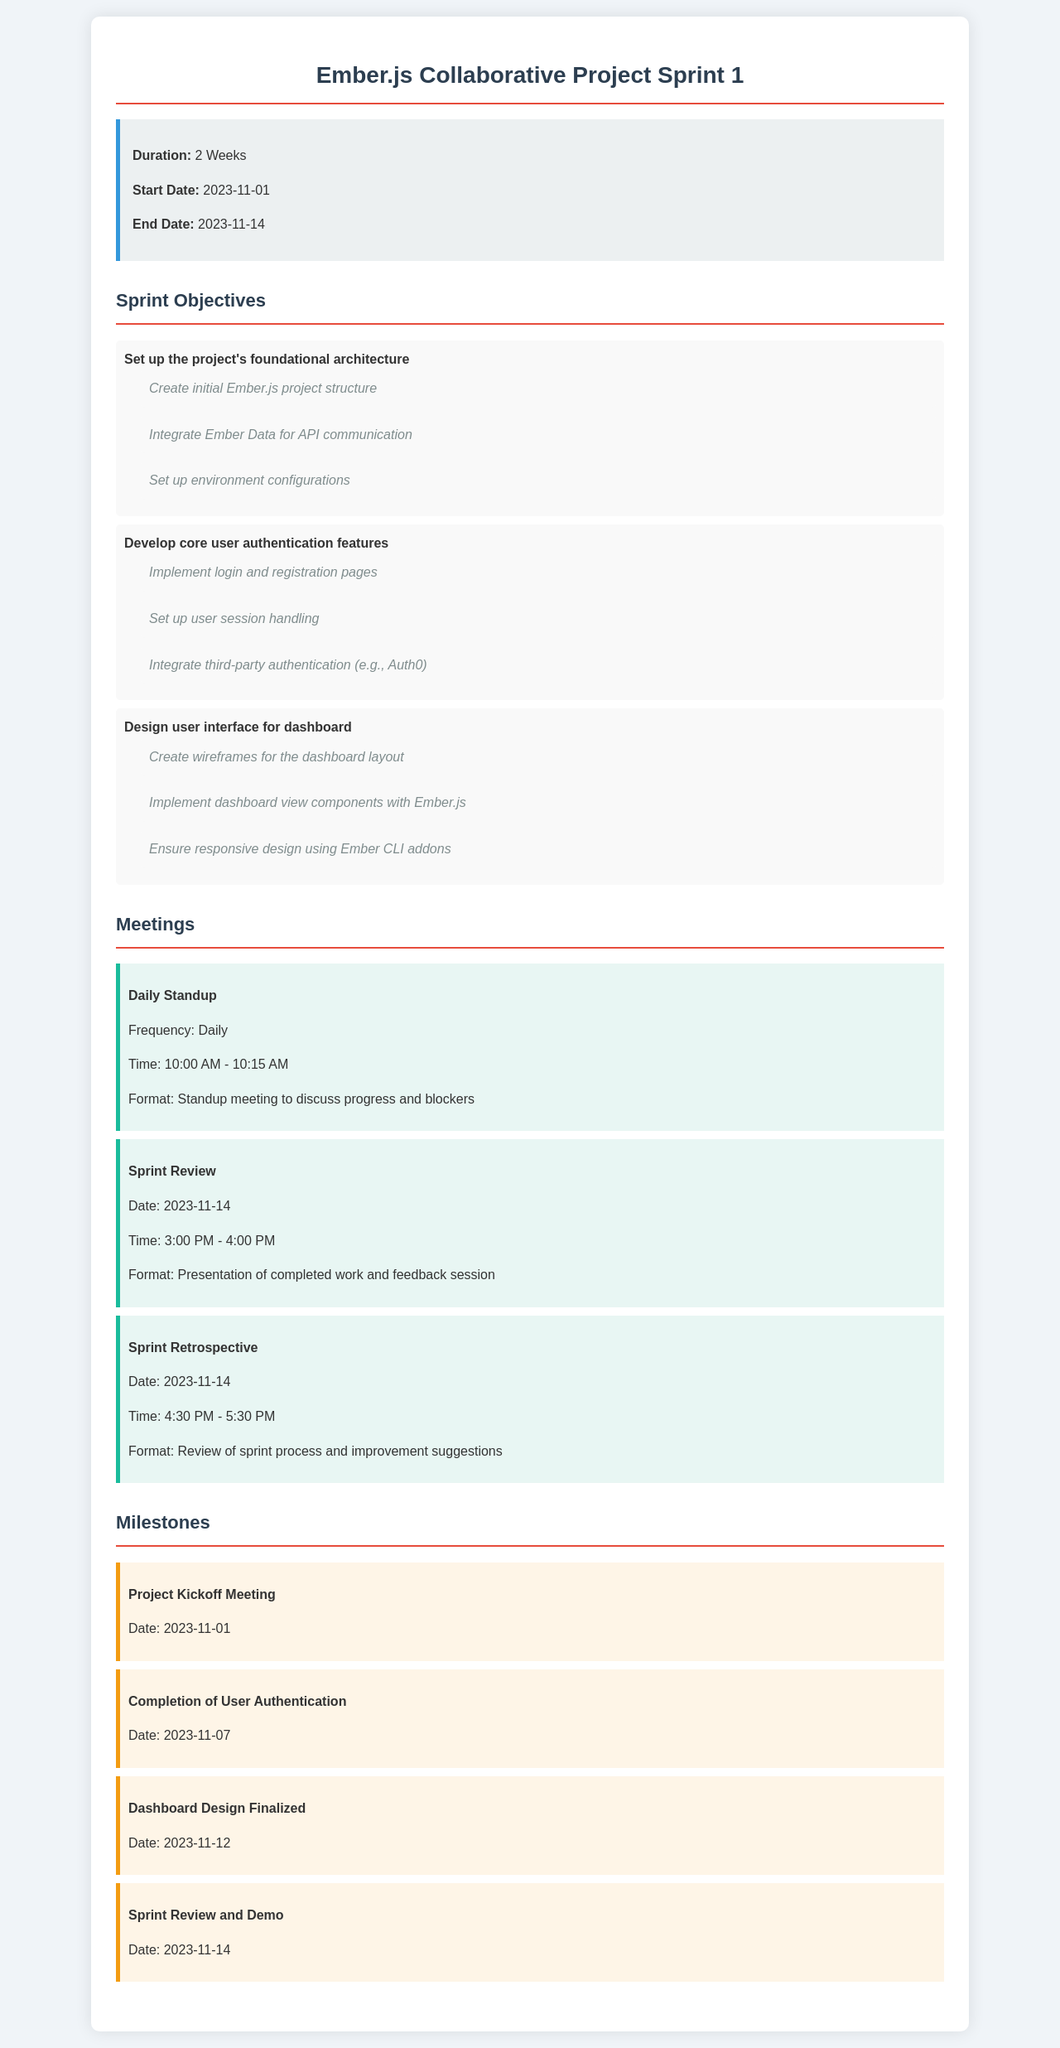what is the duration of the sprint? The duration of the sprint is specified at the beginning of the document.
Answer: 2 Weeks when does the sprint start? The start date for the sprint is mentioned in the sprint info section.
Answer: 2023-11-01 what is one of the sprint objectives? The objectives are listed in the objectives section, and one can be selected from the list provided.
Answer: Set up the project's foundational architecture when is the Sprint Review meeting scheduled? The date for the Sprint Review meeting is clearly stated in the meetings section.
Answer: 2023-11-14 how many milestones are listed in the document? The milestones section lists the number of milestones that are included in the document.
Answer: 4 what is the frequency of the Daily Standup meeting? The frequency of the Daily Standup meeting can be found in the meetings section.
Answer: Daily when is the completion of User Authentication milestone? The date for this milestone is found in the milestones section.
Answer: 2023-11-07 what is the purpose of the Sprint Retrospective meeting? The purpose of the Sprint Retrospective meeting is described in the format section of the meetings.
Answer: Review of sprint process and improvement suggestions who is responsible for logging and session handling? This responsibility is part of the user authentication features detailed in the objectives.
Answer: Developer 